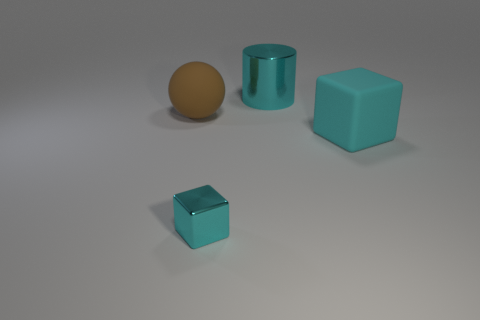Add 3 big matte objects. How many objects exist? 7 Subtract all balls. How many objects are left? 3 Add 4 yellow rubber objects. How many yellow rubber objects exist? 4 Subtract 1 brown balls. How many objects are left? 3 Subtract all green metal cylinders. Subtract all large brown objects. How many objects are left? 3 Add 2 large cyan cubes. How many large cyan cubes are left? 3 